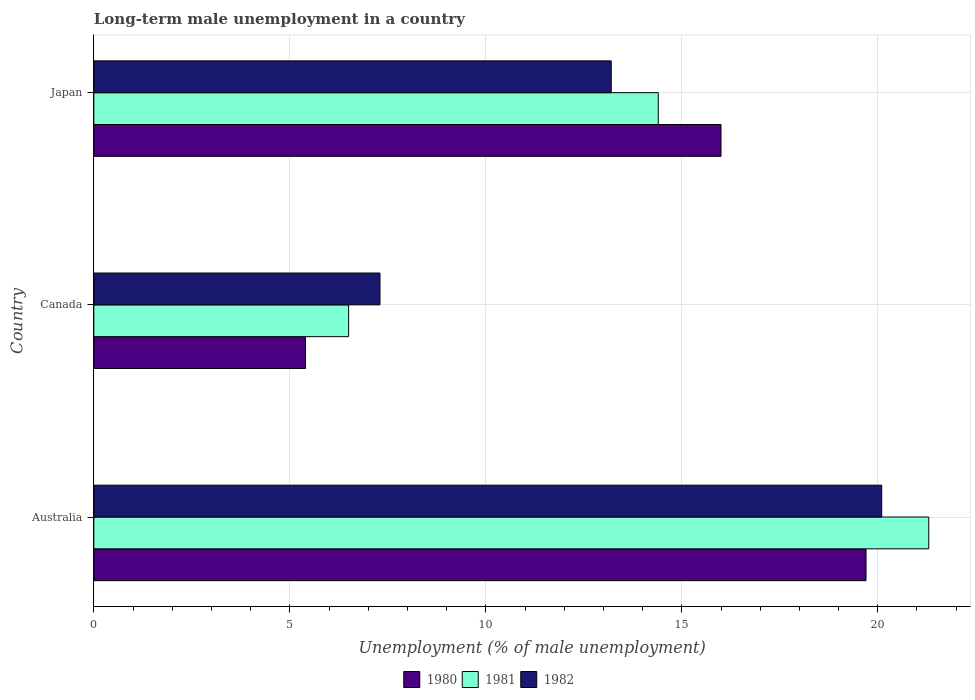How many different coloured bars are there?
Your answer should be compact. 3. How many groups of bars are there?
Your answer should be very brief. 3. Are the number of bars on each tick of the Y-axis equal?
Your answer should be compact. Yes. How many bars are there on the 3rd tick from the top?
Give a very brief answer. 3. What is the percentage of long-term unemployed male population in 1982 in Canada?
Your response must be concise. 7.3. Across all countries, what is the maximum percentage of long-term unemployed male population in 1980?
Provide a succinct answer. 19.7. Across all countries, what is the minimum percentage of long-term unemployed male population in 1980?
Your answer should be compact. 5.4. What is the total percentage of long-term unemployed male population in 1982 in the graph?
Provide a short and direct response. 40.6. What is the difference between the percentage of long-term unemployed male population in 1980 in Australia and that in Japan?
Your answer should be compact. 3.7. What is the difference between the percentage of long-term unemployed male population in 1980 in Canada and the percentage of long-term unemployed male population in 1981 in Australia?
Your answer should be very brief. -15.9. What is the average percentage of long-term unemployed male population in 1980 per country?
Give a very brief answer. 13.7. What is the difference between the percentage of long-term unemployed male population in 1980 and percentage of long-term unemployed male population in 1981 in Australia?
Ensure brevity in your answer.  -1.6. In how many countries, is the percentage of long-term unemployed male population in 1981 greater than 12 %?
Keep it short and to the point. 2. What is the ratio of the percentage of long-term unemployed male population in 1982 in Canada to that in Japan?
Ensure brevity in your answer.  0.55. What is the difference between the highest and the second highest percentage of long-term unemployed male population in 1980?
Provide a short and direct response. 3.7. What is the difference between the highest and the lowest percentage of long-term unemployed male population in 1982?
Ensure brevity in your answer.  12.8. In how many countries, is the percentage of long-term unemployed male population in 1980 greater than the average percentage of long-term unemployed male population in 1980 taken over all countries?
Ensure brevity in your answer.  2. Is the sum of the percentage of long-term unemployed male population in 1981 in Australia and Japan greater than the maximum percentage of long-term unemployed male population in 1982 across all countries?
Give a very brief answer. Yes. What does the 2nd bar from the top in Canada represents?
Give a very brief answer. 1981. Is it the case that in every country, the sum of the percentage of long-term unemployed male population in 1981 and percentage of long-term unemployed male population in 1980 is greater than the percentage of long-term unemployed male population in 1982?
Offer a very short reply. Yes. How many bars are there?
Your response must be concise. 9. Are all the bars in the graph horizontal?
Your response must be concise. Yes. How many countries are there in the graph?
Your answer should be very brief. 3. Are the values on the major ticks of X-axis written in scientific E-notation?
Provide a succinct answer. No. Where does the legend appear in the graph?
Your answer should be very brief. Bottom center. What is the title of the graph?
Ensure brevity in your answer.  Long-term male unemployment in a country. What is the label or title of the X-axis?
Provide a short and direct response. Unemployment (% of male unemployment). What is the Unemployment (% of male unemployment) in 1980 in Australia?
Make the answer very short. 19.7. What is the Unemployment (% of male unemployment) in 1981 in Australia?
Make the answer very short. 21.3. What is the Unemployment (% of male unemployment) of 1982 in Australia?
Keep it short and to the point. 20.1. What is the Unemployment (% of male unemployment) in 1980 in Canada?
Ensure brevity in your answer.  5.4. What is the Unemployment (% of male unemployment) in 1981 in Canada?
Ensure brevity in your answer.  6.5. What is the Unemployment (% of male unemployment) in 1982 in Canada?
Make the answer very short. 7.3. What is the Unemployment (% of male unemployment) in 1981 in Japan?
Your response must be concise. 14.4. What is the Unemployment (% of male unemployment) in 1982 in Japan?
Provide a short and direct response. 13.2. Across all countries, what is the maximum Unemployment (% of male unemployment) in 1980?
Your answer should be very brief. 19.7. Across all countries, what is the maximum Unemployment (% of male unemployment) of 1981?
Keep it short and to the point. 21.3. Across all countries, what is the maximum Unemployment (% of male unemployment) in 1982?
Give a very brief answer. 20.1. Across all countries, what is the minimum Unemployment (% of male unemployment) in 1980?
Offer a terse response. 5.4. Across all countries, what is the minimum Unemployment (% of male unemployment) in 1982?
Offer a terse response. 7.3. What is the total Unemployment (% of male unemployment) of 1980 in the graph?
Your answer should be compact. 41.1. What is the total Unemployment (% of male unemployment) in 1981 in the graph?
Your answer should be very brief. 42.2. What is the total Unemployment (% of male unemployment) of 1982 in the graph?
Offer a terse response. 40.6. What is the difference between the Unemployment (% of male unemployment) of 1980 in Australia and that in Canada?
Ensure brevity in your answer.  14.3. What is the difference between the Unemployment (% of male unemployment) in 1982 in Australia and that in Canada?
Keep it short and to the point. 12.8. What is the difference between the Unemployment (% of male unemployment) of 1980 in Australia and that in Japan?
Make the answer very short. 3.7. What is the difference between the Unemployment (% of male unemployment) in 1981 in Australia and that in Japan?
Your response must be concise. 6.9. What is the difference between the Unemployment (% of male unemployment) in 1982 in Australia and that in Japan?
Give a very brief answer. 6.9. What is the difference between the Unemployment (% of male unemployment) of 1980 in Canada and that in Japan?
Offer a very short reply. -10.6. What is the difference between the Unemployment (% of male unemployment) of 1982 in Canada and that in Japan?
Offer a terse response. -5.9. What is the difference between the Unemployment (% of male unemployment) of 1980 in Australia and the Unemployment (% of male unemployment) of 1981 in Canada?
Your response must be concise. 13.2. What is the difference between the Unemployment (% of male unemployment) in 1980 in Australia and the Unemployment (% of male unemployment) in 1982 in Canada?
Provide a short and direct response. 12.4. What is the difference between the Unemployment (% of male unemployment) in 1981 in Australia and the Unemployment (% of male unemployment) in 1982 in Canada?
Ensure brevity in your answer.  14. What is the difference between the Unemployment (% of male unemployment) in 1980 in Australia and the Unemployment (% of male unemployment) in 1981 in Japan?
Your response must be concise. 5.3. What is the difference between the Unemployment (% of male unemployment) in 1980 in Australia and the Unemployment (% of male unemployment) in 1982 in Japan?
Keep it short and to the point. 6.5. What is the average Unemployment (% of male unemployment) of 1980 per country?
Provide a succinct answer. 13.7. What is the average Unemployment (% of male unemployment) of 1981 per country?
Provide a succinct answer. 14.07. What is the average Unemployment (% of male unemployment) of 1982 per country?
Ensure brevity in your answer.  13.53. What is the difference between the Unemployment (% of male unemployment) in 1980 and Unemployment (% of male unemployment) in 1981 in Australia?
Your answer should be very brief. -1.6. What is the difference between the Unemployment (% of male unemployment) of 1980 and Unemployment (% of male unemployment) of 1982 in Australia?
Provide a short and direct response. -0.4. What is the difference between the Unemployment (% of male unemployment) of 1980 and Unemployment (% of male unemployment) of 1981 in Canada?
Offer a terse response. -1.1. What is the difference between the Unemployment (% of male unemployment) in 1981 and Unemployment (% of male unemployment) in 1982 in Canada?
Give a very brief answer. -0.8. What is the difference between the Unemployment (% of male unemployment) in 1980 and Unemployment (% of male unemployment) in 1981 in Japan?
Offer a terse response. 1.6. What is the difference between the Unemployment (% of male unemployment) of 1980 and Unemployment (% of male unemployment) of 1982 in Japan?
Make the answer very short. 2.8. What is the ratio of the Unemployment (% of male unemployment) of 1980 in Australia to that in Canada?
Keep it short and to the point. 3.65. What is the ratio of the Unemployment (% of male unemployment) in 1981 in Australia to that in Canada?
Give a very brief answer. 3.28. What is the ratio of the Unemployment (% of male unemployment) in 1982 in Australia to that in Canada?
Give a very brief answer. 2.75. What is the ratio of the Unemployment (% of male unemployment) in 1980 in Australia to that in Japan?
Ensure brevity in your answer.  1.23. What is the ratio of the Unemployment (% of male unemployment) in 1981 in Australia to that in Japan?
Your response must be concise. 1.48. What is the ratio of the Unemployment (% of male unemployment) in 1982 in Australia to that in Japan?
Make the answer very short. 1.52. What is the ratio of the Unemployment (% of male unemployment) of 1980 in Canada to that in Japan?
Your answer should be compact. 0.34. What is the ratio of the Unemployment (% of male unemployment) in 1981 in Canada to that in Japan?
Offer a terse response. 0.45. What is the ratio of the Unemployment (% of male unemployment) in 1982 in Canada to that in Japan?
Offer a very short reply. 0.55. What is the difference between the highest and the lowest Unemployment (% of male unemployment) in 1982?
Ensure brevity in your answer.  12.8. 